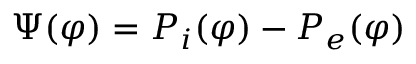<formula> <loc_0><loc_0><loc_500><loc_500>\Psi ( \varphi ) = P _ { i } ( \varphi ) - P _ { e } ( \varphi )</formula> 